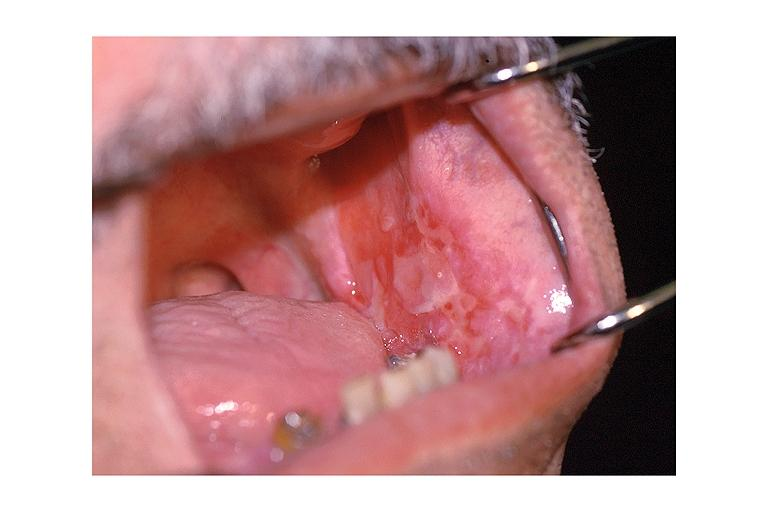what does this image show?
Answer the question using a single word or phrase. Cicatricial pemphigoid 